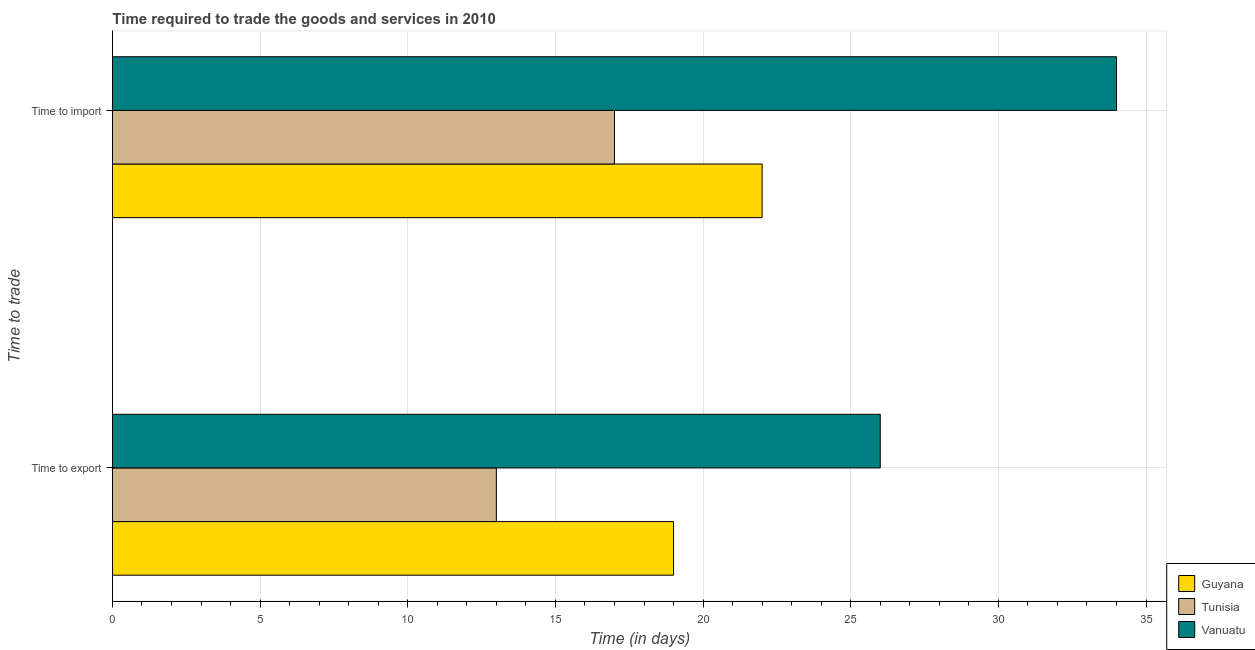How many different coloured bars are there?
Provide a succinct answer. 3. Are the number of bars on each tick of the Y-axis equal?
Ensure brevity in your answer.  Yes. How many bars are there on the 1st tick from the top?
Your answer should be compact. 3. What is the label of the 2nd group of bars from the top?
Provide a succinct answer. Time to export. What is the time to import in Guyana?
Your response must be concise. 22. Across all countries, what is the maximum time to import?
Your answer should be very brief. 34. Across all countries, what is the minimum time to import?
Keep it short and to the point. 17. In which country was the time to import maximum?
Offer a very short reply. Vanuatu. In which country was the time to import minimum?
Your answer should be very brief. Tunisia. What is the total time to export in the graph?
Your answer should be compact. 58. What is the difference between the time to import in Vanuatu and that in Guyana?
Provide a succinct answer. 12. What is the difference between the time to import in Guyana and the time to export in Tunisia?
Ensure brevity in your answer.  9. What is the average time to export per country?
Offer a very short reply. 19.33. What is the difference between the time to export and time to import in Guyana?
Keep it short and to the point. -3. What is the ratio of the time to import in Tunisia to that in Guyana?
Provide a succinct answer. 0.77. What does the 2nd bar from the top in Time to export represents?
Your response must be concise. Tunisia. What does the 3rd bar from the bottom in Time to import represents?
Keep it short and to the point. Vanuatu. How many bars are there?
Your response must be concise. 6. What is the difference between two consecutive major ticks on the X-axis?
Ensure brevity in your answer.  5. Does the graph contain grids?
Make the answer very short. Yes. Where does the legend appear in the graph?
Offer a very short reply. Bottom right. How many legend labels are there?
Offer a very short reply. 3. What is the title of the graph?
Keep it short and to the point. Time required to trade the goods and services in 2010. Does "New Caledonia" appear as one of the legend labels in the graph?
Your answer should be compact. No. What is the label or title of the X-axis?
Offer a terse response. Time (in days). What is the label or title of the Y-axis?
Ensure brevity in your answer.  Time to trade. What is the Time (in days) of Guyana in Time to export?
Keep it short and to the point. 19. What is the Time (in days) of Tunisia in Time to export?
Offer a very short reply. 13. What is the Time (in days) in Vanuatu in Time to export?
Your response must be concise. 26. What is the Time (in days) in Tunisia in Time to import?
Make the answer very short. 17. What is the Time (in days) in Vanuatu in Time to import?
Offer a very short reply. 34. Across all Time to trade, what is the minimum Time (in days) of Vanuatu?
Your response must be concise. 26. What is the total Time (in days) in Guyana in the graph?
Your response must be concise. 41. What is the total Time (in days) in Tunisia in the graph?
Your answer should be very brief. 30. What is the total Time (in days) of Vanuatu in the graph?
Provide a short and direct response. 60. What is the difference between the Time (in days) in Guyana in Time to export and that in Time to import?
Provide a succinct answer. -3. What is the difference between the Time (in days) in Tunisia in Time to export and that in Time to import?
Your response must be concise. -4. What is the difference between the Time (in days) of Vanuatu in Time to export and that in Time to import?
Your answer should be very brief. -8. What is the difference between the Time (in days) in Guyana in Time to export and the Time (in days) in Tunisia in Time to import?
Provide a short and direct response. 2. What is the difference between the Time (in days) in Guyana in Time to export and the Time (in days) in Vanuatu in Time to import?
Offer a terse response. -15. What is the difference between the Time (in days) in Tunisia in Time to export and the Time (in days) in Vanuatu in Time to import?
Provide a short and direct response. -21. What is the average Time (in days) of Guyana per Time to trade?
Your response must be concise. 20.5. What is the average Time (in days) in Tunisia per Time to trade?
Your answer should be very brief. 15. What is the difference between the Time (in days) of Guyana and Time (in days) of Tunisia in Time to export?
Offer a terse response. 6. What is the difference between the Time (in days) of Guyana and Time (in days) of Vanuatu in Time to export?
Your answer should be compact. -7. What is the difference between the Time (in days) in Tunisia and Time (in days) in Vanuatu in Time to export?
Make the answer very short. -13. What is the difference between the Time (in days) in Guyana and Time (in days) in Vanuatu in Time to import?
Your answer should be compact. -12. What is the difference between the Time (in days) in Tunisia and Time (in days) in Vanuatu in Time to import?
Your answer should be very brief. -17. What is the ratio of the Time (in days) of Guyana in Time to export to that in Time to import?
Provide a succinct answer. 0.86. What is the ratio of the Time (in days) in Tunisia in Time to export to that in Time to import?
Make the answer very short. 0.76. What is the ratio of the Time (in days) in Vanuatu in Time to export to that in Time to import?
Make the answer very short. 0.76. What is the difference between the highest and the second highest Time (in days) in Guyana?
Your answer should be compact. 3. What is the difference between the highest and the lowest Time (in days) of Guyana?
Your answer should be very brief. 3. 